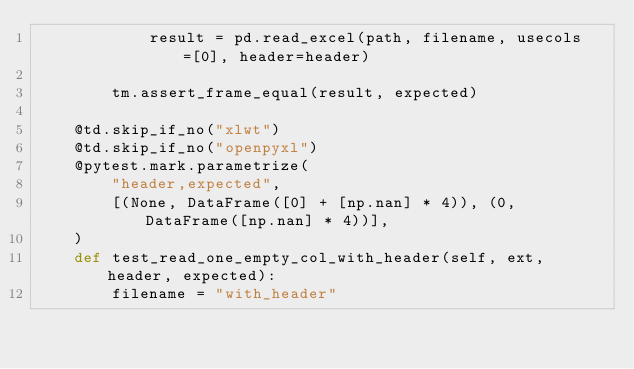<code> <loc_0><loc_0><loc_500><loc_500><_Python_>            result = pd.read_excel(path, filename, usecols=[0], header=header)

        tm.assert_frame_equal(result, expected)

    @td.skip_if_no("xlwt")
    @td.skip_if_no("openpyxl")
    @pytest.mark.parametrize(
        "header,expected",
        [(None, DataFrame([0] + [np.nan] * 4)), (0, DataFrame([np.nan] * 4))],
    )
    def test_read_one_empty_col_with_header(self, ext, header, expected):
        filename = "with_header"</code> 